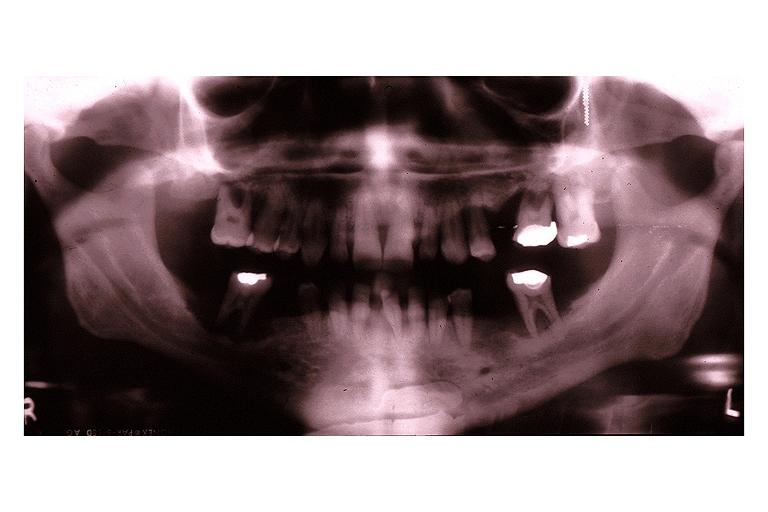s nervous present?
Answer the question using a single word or phrase. No 